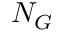Convert formula to latex. <formula><loc_0><loc_0><loc_500><loc_500>N _ { G }</formula> 